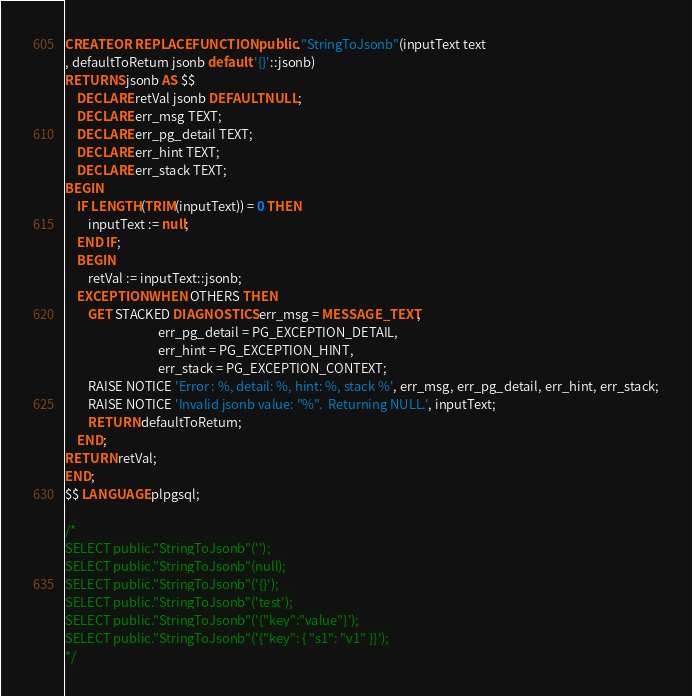<code> <loc_0><loc_0><loc_500><loc_500><_SQL_>CREATE OR REPLACE FUNCTION public."StringToJsonb"(inputText text
, defaultToReturn jsonb default '{}'::jsonb)
RETURNS jsonb AS $$
    DECLARE retVal jsonb DEFAULT NULL;
    DECLARE err_msg TEXT;
    DECLARE err_pg_detail TEXT;
    DECLARE err_hint TEXT;
    DECLARE err_stack TEXT;
BEGIN
    IF LENGTH(TRIM(inputText)) = 0 THEN
        inputText := null;
    END IF;
    BEGIN
        retVal := inputText::jsonb;
    EXCEPTION WHEN OTHERS THEN
        GET STACKED DIAGNOSTICS err_msg = MESSAGE_TEXT,
                                err_pg_detail = PG_EXCEPTION_DETAIL,
                                err_hint = PG_EXCEPTION_HINT,
                                err_stack = PG_EXCEPTION_CONTEXT;
        RAISE NOTICE 'Error : %, detail: %, hint: %, stack %', err_msg, err_pg_detail, err_hint, err_stack;
        RAISE NOTICE 'Invalid jsonb value: "%".  Returning NULL.', inputText;
        RETURN defaultToReturn;
    END;
RETURN retVal;
END;
$$ LANGUAGE plpgsql;

/*
SELECT public."StringToJsonb"('');
SELECT public."StringToJsonb"(null);
SELECT public."StringToJsonb"('{}');
SELECT public."StringToJsonb"('test');
SELECT public."StringToJsonb"('{"key":"value"}');
SELECT public."StringToJsonb"('{"key": { "s1": "v1" }}');
*/</code> 